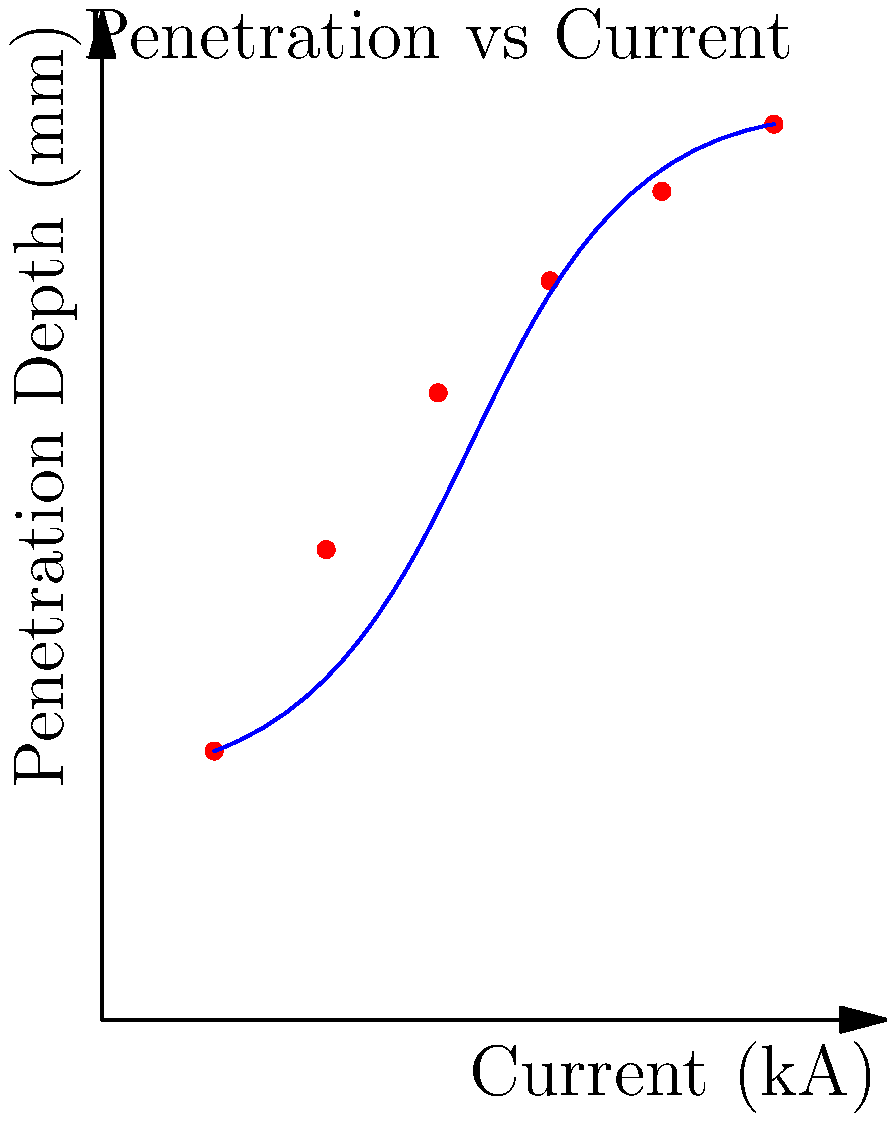Based on the graph showing the relationship between welding current and penetration depth, which mathematical model would best describe the trend for predicting weld penetration depth? Consider the curve's shape and the nature of the welding process. To determine the best mathematical model for predicting weld penetration depth based on the given graph, let's analyze the relationship step-by-step:

1. Observe the curve shape: The curve shows a non-linear relationship between current and penetration depth.

2. Initial rapid increase: At lower current values, there's a steep increase in penetration depth.

3. Gradual leveling: As current increases, the rate of increase in penetration depth slows down.

4. Asymptotic behavior: The curve appears to approach a maximum value of penetration depth as current continues to increase.

5. Physical interpretation: This behavior aligns with the welding process, where increasing current initially leads to significant increases in penetration, but eventually, heat dissipation and other factors limit further penetration.

6. Mathematical models: Consider common non-linear models:
   a) Linear: Doesn't fit the curve's shape.
   b) Polynomial: Could fit but doesn't capture the asymptotic behavior well.
   c) Exponential: Doesn't match the leveling off at higher currents.
   d) Logarithmic: Captures the initial rapid increase and gradual leveling, but doesn't have an upper limit.
   e) Power law: Similar issues to logarithmic.
   f) Saturation growth model: Matches the observed behavior, including the asymptotic approach to a maximum value.

7. Best fit: The saturation growth model, often expressed as $y = a(1-e^{-bx})$, where $y$ is penetration depth, $x$ is current, and $a$ and $b$ are constants, best describes the observed trend.

This model accurately represents the initial rapid increase, gradual leveling, and asymptotic behavior seen in the welding current vs. penetration depth relationship.
Answer: Saturation growth model 